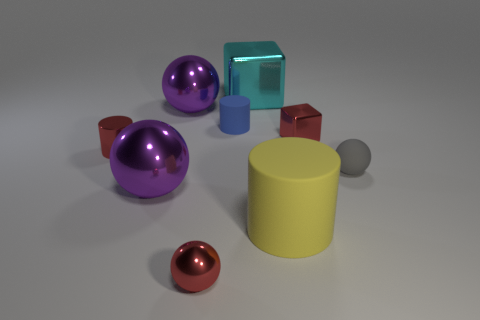Imagine this setup is part of a children's game, can you describe a possible rule involving the red object? A possible game rule could be: 'Roll the red sphere to knock over the brown cube. If you succeed without touching the other objects, you earn a point!' 